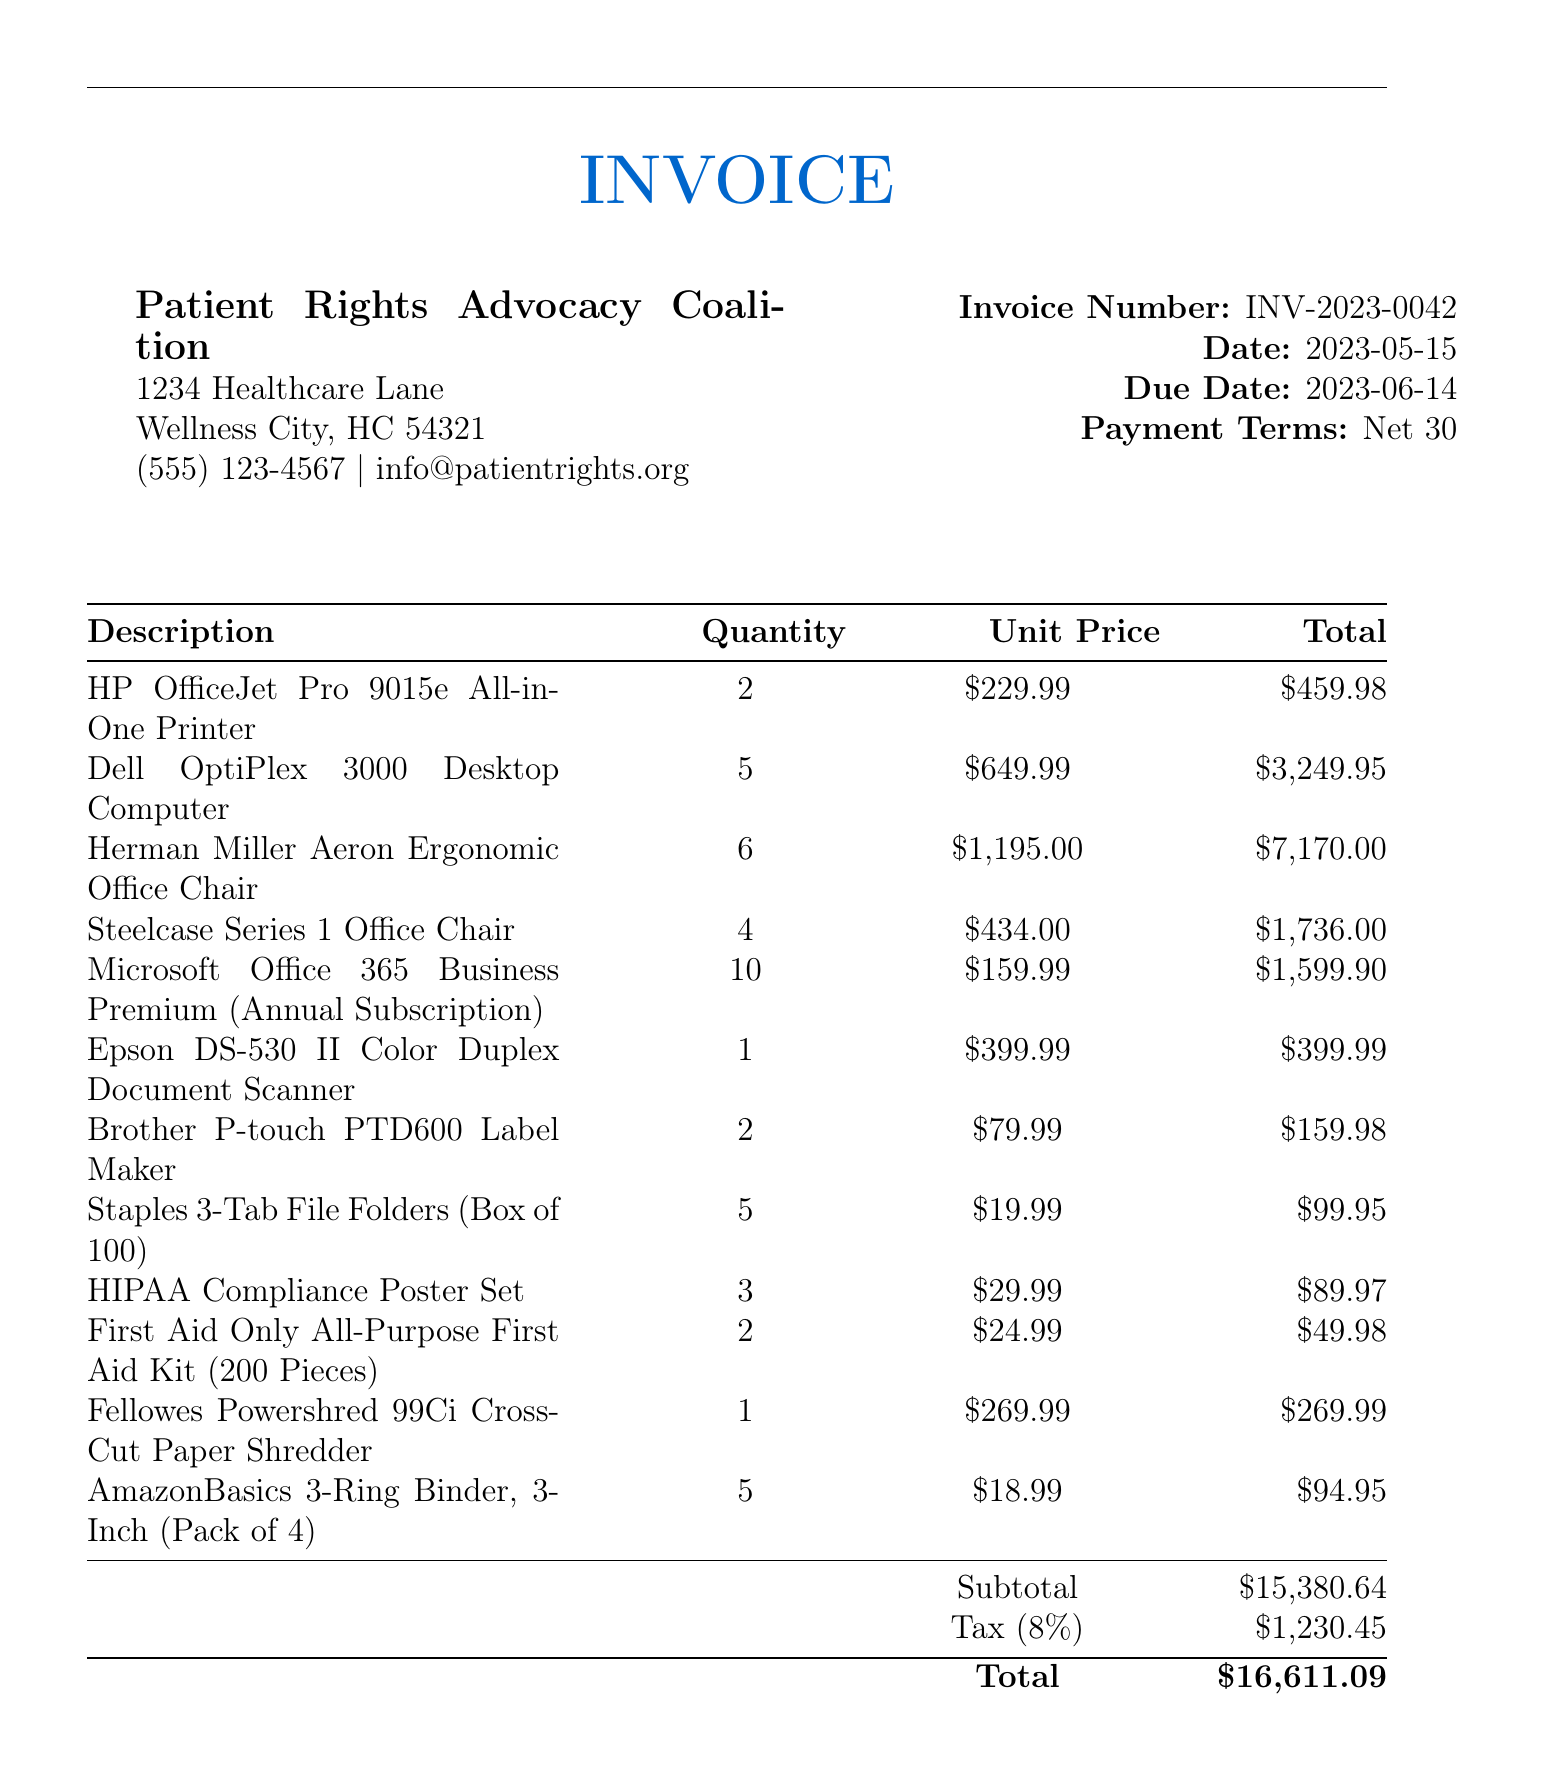What is the invoice number? The invoice number is stated clearly in the document under invoicedetails.
Answer: INV-2023-0042 What is the total amount due? The total amount due is found in the summary at the bottom of the invoice.
Answer: $16,611.09 How many Dell OptiPlex 3000 Desktop Computers are listed? The number of Dell OptiPlex 3000 Desktop Computers is specified next to its description in the itemized list.
Answer: 5 What is the tax rate applied? The tax rate is mentioned alongside the tax amount in the document summary.
Answer: 8% What is the address of the organization? The organization's address is provided at the beginning of the invoice under its header.
Answer: 1234 Healthcare Lane, Wellness City, HC 54321 What is the due date for the invoice? The due date is clearly provided in the invoicedetails section of the document.
Answer: 2023-06-14 How many Herman Miller Aeron Ergonomic Office Chairs were ordered? The quantity of Herman Miller Aeron Ergonomic Office Chairs ordered can be found next to its description in the item table.
Answer: 6 What payment terms are stated in the invoice? The payment terms are included in the invoicedetails section of the document.
Answer: Net 30 What is the subtotal amount before tax? The subtotal amount is located in the summary section of the invoice.
Answer: $15,380.64 